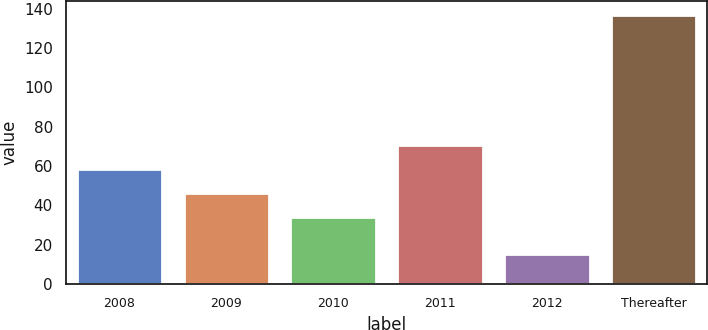Convert chart to OTSL. <chart><loc_0><loc_0><loc_500><loc_500><bar_chart><fcel>2008<fcel>2009<fcel>2010<fcel>2011<fcel>2012<fcel>Thereafter<nl><fcel>58.4<fcel>46.2<fcel>34<fcel>70.6<fcel>15<fcel>137<nl></chart> 